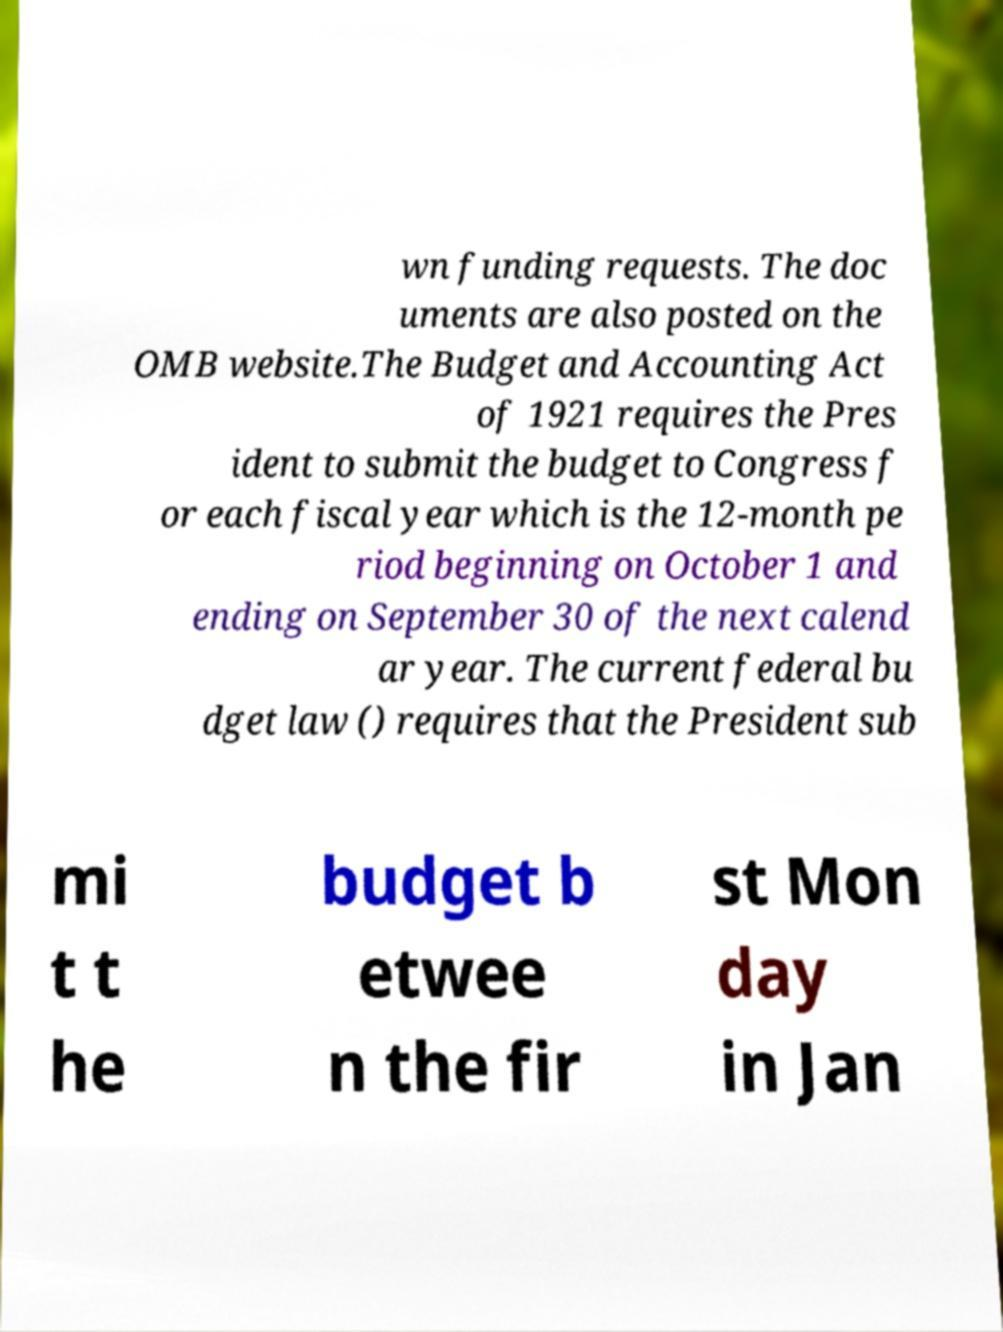Please read and relay the text visible in this image. What does it say? wn funding requests. The doc uments are also posted on the OMB website.The Budget and Accounting Act of 1921 requires the Pres ident to submit the budget to Congress f or each fiscal year which is the 12-month pe riod beginning on October 1 and ending on September 30 of the next calend ar year. The current federal bu dget law () requires that the President sub mi t t he budget b etwee n the fir st Mon day in Jan 